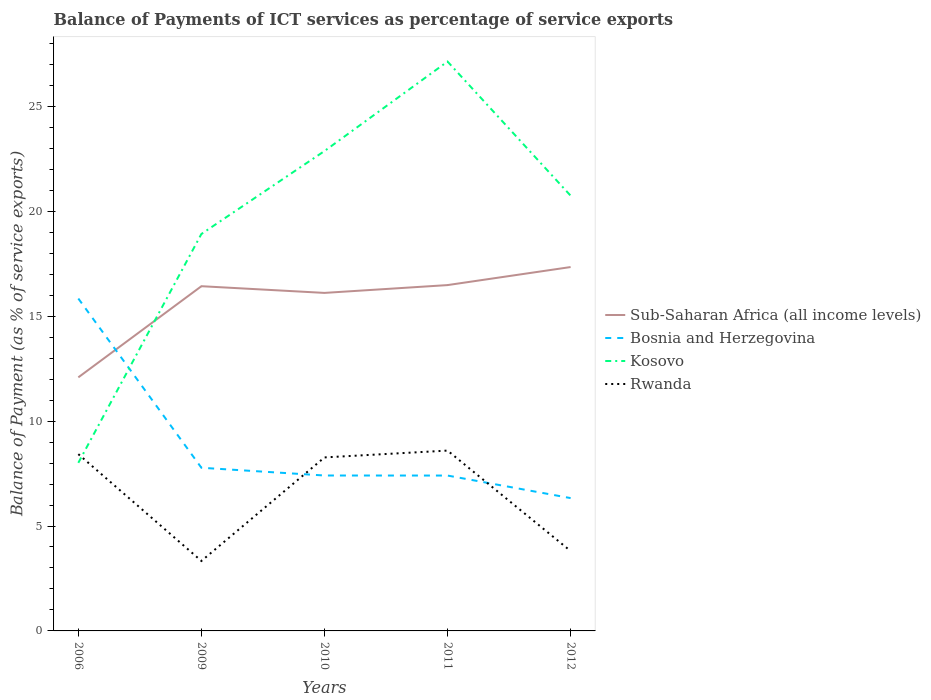Does the line corresponding to Sub-Saharan Africa (all income levels) intersect with the line corresponding to Rwanda?
Provide a succinct answer. No. Is the number of lines equal to the number of legend labels?
Your answer should be compact. Yes. Across all years, what is the maximum balance of payments of ICT services in Rwanda?
Your response must be concise. 3.33. What is the total balance of payments of ICT services in Kosovo in the graph?
Keep it short and to the point. -4.26. What is the difference between the highest and the second highest balance of payments of ICT services in Sub-Saharan Africa (all income levels)?
Make the answer very short. 5.26. What is the difference between the highest and the lowest balance of payments of ICT services in Bosnia and Herzegovina?
Offer a terse response. 1. How many lines are there?
Your response must be concise. 4. Are the values on the major ticks of Y-axis written in scientific E-notation?
Keep it short and to the point. No. Does the graph contain any zero values?
Offer a very short reply. No. Does the graph contain grids?
Provide a succinct answer. No. Where does the legend appear in the graph?
Make the answer very short. Center right. How many legend labels are there?
Ensure brevity in your answer.  4. How are the legend labels stacked?
Ensure brevity in your answer.  Vertical. What is the title of the graph?
Provide a succinct answer. Balance of Payments of ICT services as percentage of service exports. Does "Senegal" appear as one of the legend labels in the graph?
Make the answer very short. No. What is the label or title of the X-axis?
Give a very brief answer. Years. What is the label or title of the Y-axis?
Give a very brief answer. Balance of Payment (as % of service exports). What is the Balance of Payment (as % of service exports) in Sub-Saharan Africa (all income levels) in 2006?
Ensure brevity in your answer.  12.08. What is the Balance of Payment (as % of service exports) in Bosnia and Herzegovina in 2006?
Your answer should be compact. 15.84. What is the Balance of Payment (as % of service exports) of Kosovo in 2006?
Offer a very short reply. 8.01. What is the Balance of Payment (as % of service exports) in Rwanda in 2006?
Offer a terse response. 8.42. What is the Balance of Payment (as % of service exports) in Sub-Saharan Africa (all income levels) in 2009?
Your answer should be compact. 16.43. What is the Balance of Payment (as % of service exports) in Bosnia and Herzegovina in 2009?
Keep it short and to the point. 7.78. What is the Balance of Payment (as % of service exports) of Kosovo in 2009?
Keep it short and to the point. 18.92. What is the Balance of Payment (as % of service exports) of Rwanda in 2009?
Make the answer very short. 3.33. What is the Balance of Payment (as % of service exports) of Sub-Saharan Africa (all income levels) in 2010?
Provide a short and direct response. 16.11. What is the Balance of Payment (as % of service exports) in Bosnia and Herzegovina in 2010?
Make the answer very short. 7.41. What is the Balance of Payment (as % of service exports) of Kosovo in 2010?
Your answer should be compact. 22.87. What is the Balance of Payment (as % of service exports) in Rwanda in 2010?
Ensure brevity in your answer.  8.27. What is the Balance of Payment (as % of service exports) of Sub-Saharan Africa (all income levels) in 2011?
Ensure brevity in your answer.  16.48. What is the Balance of Payment (as % of service exports) of Bosnia and Herzegovina in 2011?
Your response must be concise. 7.4. What is the Balance of Payment (as % of service exports) of Kosovo in 2011?
Your response must be concise. 27.13. What is the Balance of Payment (as % of service exports) of Rwanda in 2011?
Offer a terse response. 8.59. What is the Balance of Payment (as % of service exports) of Sub-Saharan Africa (all income levels) in 2012?
Offer a very short reply. 17.34. What is the Balance of Payment (as % of service exports) in Bosnia and Herzegovina in 2012?
Provide a succinct answer. 6.33. What is the Balance of Payment (as % of service exports) in Kosovo in 2012?
Keep it short and to the point. 20.74. What is the Balance of Payment (as % of service exports) of Rwanda in 2012?
Provide a short and direct response. 3.81. Across all years, what is the maximum Balance of Payment (as % of service exports) in Sub-Saharan Africa (all income levels)?
Your answer should be compact. 17.34. Across all years, what is the maximum Balance of Payment (as % of service exports) in Bosnia and Herzegovina?
Your answer should be compact. 15.84. Across all years, what is the maximum Balance of Payment (as % of service exports) in Kosovo?
Provide a succinct answer. 27.13. Across all years, what is the maximum Balance of Payment (as % of service exports) in Rwanda?
Provide a short and direct response. 8.59. Across all years, what is the minimum Balance of Payment (as % of service exports) in Sub-Saharan Africa (all income levels)?
Make the answer very short. 12.08. Across all years, what is the minimum Balance of Payment (as % of service exports) of Bosnia and Herzegovina?
Provide a succinct answer. 6.33. Across all years, what is the minimum Balance of Payment (as % of service exports) in Kosovo?
Your response must be concise. 8.01. Across all years, what is the minimum Balance of Payment (as % of service exports) of Rwanda?
Give a very brief answer. 3.33. What is the total Balance of Payment (as % of service exports) in Sub-Saharan Africa (all income levels) in the graph?
Your response must be concise. 78.44. What is the total Balance of Payment (as % of service exports) of Bosnia and Herzegovina in the graph?
Offer a very short reply. 44.76. What is the total Balance of Payment (as % of service exports) in Kosovo in the graph?
Your answer should be very brief. 97.67. What is the total Balance of Payment (as % of service exports) of Rwanda in the graph?
Offer a very short reply. 32.43. What is the difference between the Balance of Payment (as % of service exports) in Sub-Saharan Africa (all income levels) in 2006 and that in 2009?
Give a very brief answer. -4.34. What is the difference between the Balance of Payment (as % of service exports) of Bosnia and Herzegovina in 2006 and that in 2009?
Ensure brevity in your answer.  8.06. What is the difference between the Balance of Payment (as % of service exports) in Kosovo in 2006 and that in 2009?
Provide a short and direct response. -10.91. What is the difference between the Balance of Payment (as % of service exports) in Rwanda in 2006 and that in 2009?
Offer a terse response. 5.09. What is the difference between the Balance of Payment (as % of service exports) of Sub-Saharan Africa (all income levels) in 2006 and that in 2010?
Your answer should be very brief. -4.02. What is the difference between the Balance of Payment (as % of service exports) of Bosnia and Herzegovina in 2006 and that in 2010?
Provide a short and direct response. 8.43. What is the difference between the Balance of Payment (as % of service exports) of Kosovo in 2006 and that in 2010?
Keep it short and to the point. -14.86. What is the difference between the Balance of Payment (as % of service exports) of Rwanda in 2006 and that in 2010?
Make the answer very short. 0.16. What is the difference between the Balance of Payment (as % of service exports) in Sub-Saharan Africa (all income levels) in 2006 and that in 2011?
Your answer should be very brief. -4.4. What is the difference between the Balance of Payment (as % of service exports) in Bosnia and Herzegovina in 2006 and that in 2011?
Offer a very short reply. 8.44. What is the difference between the Balance of Payment (as % of service exports) of Kosovo in 2006 and that in 2011?
Your response must be concise. -19.12. What is the difference between the Balance of Payment (as % of service exports) of Rwanda in 2006 and that in 2011?
Keep it short and to the point. -0.17. What is the difference between the Balance of Payment (as % of service exports) of Sub-Saharan Africa (all income levels) in 2006 and that in 2012?
Offer a very short reply. -5.26. What is the difference between the Balance of Payment (as % of service exports) of Bosnia and Herzegovina in 2006 and that in 2012?
Make the answer very short. 9.51. What is the difference between the Balance of Payment (as % of service exports) of Kosovo in 2006 and that in 2012?
Your answer should be compact. -12.73. What is the difference between the Balance of Payment (as % of service exports) of Rwanda in 2006 and that in 2012?
Provide a succinct answer. 4.62. What is the difference between the Balance of Payment (as % of service exports) in Sub-Saharan Africa (all income levels) in 2009 and that in 2010?
Provide a short and direct response. 0.32. What is the difference between the Balance of Payment (as % of service exports) of Bosnia and Herzegovina in 2009 and that in 2010?
Ensure brevity in your answer.  0.37. What is the difference between the Balance of Payment (as % of service exports) in Kosovo in 2009 and that in 2010?
Ensure brevity in your answer.  -3.95. What is the difference between the Balance of Payment (as % of service exports) in Rwanda in 2009 and that in 2010?
Give a very brief answer. -4.93. What is the difference between the Balance of Payment (as % of service exports) in Sub-Saharan Africa (all income levels) in 2009 and that in 2011?
Offer a terse response. -0.05. What is the difference between the Balance of Payment (as % of service exports) of Bosnia and Herzegovina in 2009 and that in 2011?
Offer a terse response. 0.37. What is the difference between the Balance of Payment (as % of service exports) in Kosovo in 2009 and that in 2011?
Give a very brief answer. -8.22. What is the difference between the Balance of Payment (as % of service exports) of Rwanda in 2009 and that in 2011?
Provide a short and direct response. -5.26. What is the difference between the Balance of Payment (as % of service exports) of Sub-Saharan Africa (all income levels) in 2009 and that in 2012?
Offer a terse response. -0.91. What is the difference between the Balance of Payment (as % of service exports) in Bosnia and Herzegovina in 2009 and that in 2012?
Give a very brief answer. 1.45. What is the difference between the Balance of Payment (as % of service exports) in Kosovo in 2009 and that in 2012?
Make the answer very short. -1.82. What is the difference between the Balance of Payment (as % of service exports) of Rwanda in 2009 and that in 2012?
Your answer should be compact. -0.47. What is the difference between the Balance of Payment (as % of service exports) of Sub-Saharan Africa (all income levels) in 2010 and that in 2011?
Make the answer very short. -0.37. What is the difference between the Balance of Payment (as % of service exports) in Bosnia and Herzegovina in 2010 and that in 2011?
Your answer should be compact. 0. What is the difference between the Balance of Payment (as % of service exports) of Kosovo in 2010 and that in 2011?
Ensure brevity in your answer.  -4.26. What is the difference between the Balance of Payment (as % of service exports) of Rwanda in 2010 and that in 2011?
Ensure brevity in your answer.  -0.33. What is the difference between the Balance of Payment (as % of service exports) in Sub-Saharan Africa (all income levels) in 2010 and that in 2012?
Offer a very short reply. -1.23. What is the difference between the Balance of Payment (as % of service exports) in Bosnia and Herzegovina in 2010 and that in 2012?
Ensure brevity in your answer.  1.08. What is the difference between the Balance of Payment (as % of service exports) of Kosovo in 2010 and that in 2012?
Keep it short and to the point. 2.13. What is the difference between the Balance of Payment (as % of service exports) in Rwanda in 2010 and that in 2012?
Provide a succinct answer. 4.46. What is the difference between the Balance of Payment (as % of service exports) in Sub-Saharan Africa (all income levels) in 2011 and that in 2012?
Provide a succinct answer. -0.86. What is the difference between the Balance of Payment (as % of service exports) in Bosnia and Herzegovina in 2011 and that in 2012?
Offer a terse response. 1.07. What is the difference between the Balance of Payment (as % of service exports) of Kosovo in 2011 and that in 2012?
Your answer should be compact. 6.39. What is the difference between the Balance of Payment (as % of service exports) in Rwanda in 2011 and that in 2012?
Your response must be concise. 4.79. What is the difference between the Balance of Payment (as % of service exports) of Sub-Saharan Africa (all income levels) in 2006 and the Balance of Payment (as % of service exports) of Bosnia and Herzegovina in 2009?
Offer a terse response. 4.31. What is the difference between the Balance of Payment (as % of service exports) of Sub-Saharan Africa (all income levels) in 2006 and the Balance of Payment (as % of service exports) of Kosovo in 2009?
Your answer should be very brief. -6.83. What is the difference between the Balance of Payment (as % of service exports) of Sub-Saharan Africa (all income levels) in 2006 and the Balance of Payment (as % of service exports) of Rwanda in 2009?
Your answer should be compact. 8.75. What is the difference between the Balance of Payment (as % of service exports) of Bosnia and Herzegovina in 2006 and the Balance of Payment (as % of service exports) of Kosovo in 2009?
Your answer should be compact. -3.08. What is the difference between the Balance of Payment (as % of service exports) of Bosnia and Herzegovina in 2006 and the Balance of Payment (as % of service exports) of Rwanda in 2009?
Make the answer very short. 12.51. What is the difference between the Balance of Payment (as % of service exports) of Kosovo in 2006 and the Balance of Payment (as % of service exports) of Rwanda in 2009?
Your answer should be compact. 4.68. What is the difference between the Balance of Payment (as % of service exports) in Sub-Saharan Africa (all income levels) in 2006 and the Balance of Payment (as % of service exports) in Bosnia and Herzegovina in 2010?
Keep it short and to the point. 4.68. What is the difference between the Balance of Payment (as % of service exports) of Sub-Saharan Africa (all income levels) in 2006 and the Balance of Payment (as % of service exports) of Kosovo in 2010?
Provide a short and direct response. -10.78. What is the difference between the Balance of Payment (as % of service exports) in Sub-Saharan Africa (all income levels) in 2006 and the Balance of Payment (as % of service exports) in Rwanda in 2010?
Keep it short and to the point. 3.82. What is the difference between the Balance of Payment (as % of service exports) of Bosnia and Herzegovina in 2006 and the Balance of Payment (as % of service exports) of Kosovo in 2010?
Your answer should be compact. -7.03. What is the difference between the Balance of Payment (as % of service exports) of Bosnia and Herzegovina in 2006 and the Balance of Payment (as % of service exports) of Rwanda in 2010?
Provide a succinct answer. 7.57. What is the difference between the Balance of Payment (as % of service exports) in Kosovo in 2006 and the Balance of Payment (as % of service exports) in Rwanda in 2010?
Your response must be concise. -0.26. What is the difference between the Balance of Payment (as % of service exports) of Sub-Saharan Africa (all income levels) in 2006 and the Balance of Payment (as % of service exports) of Bosnia and Herzegovina in 2011?
Your response must be concise. 4.68. What is the difference between the Balance of Payment (as % of service exports) in Sub-Saharan Africa (all income levels) in 2006 and the Balance of Payment (as % of service exports) in Kosovo in 2011?
Your response must be concise. -15.05. What is the difference between the Balance of Payment (as % of service exports) of Sub-Saharan Africa (all income levels) in 2006 and the Balance of Payment (as % of service exports) of Rwanda in 2011?
Your answer should be very brief. 3.49. What is the difference between the Balance of Payment (as % of service exports) in Bosnia and Herzegovina in 2006 and the Balance of Payment (as % of service exports) in Kosovo in 2011?
Give a very brief answer. -11.29. What is the difference between the Balance of Payment (as % of service exports) in Bosnia and Herzegovina in 2006 and the Balance of Payment (as % of service exports) in Rwanda in 2011?
Ensure brevity in your answer.  7.25. What is the difference between the Balance of Payment (as % of service exports) of Kosovo in 2006 and the Balance of Payment (as % of service exports) of Rwanda in 2011?
Ensure brevity in your answer.  -0.58. What is the difference between the Balance of Payment (as % of service exports) of Sub-Saharan Africa (all income levels) in 2006 and the Balance of Payment (as % of service exports) of Bosnia and Herzegovina in 2012?
Your response must be concise. 5.75. What is the difference between the Balance of Payment (as % of service exports) in Sub-Saharan Africa (all income levels) in 2006 and the Balance of Payment (as % of service exports) in Kosovo in 2012?
Your answer should be compact. -8.66. What is the difference between the Balance of Payment (as % of service exports) of Sub-Saharan Africa (all income levels) in 2006 and the Balance of Payment (as % of service exports) of Rwanda in 2012?
Provide a short and direct response. 8.28. What is the difference between the Balance of Payment (as % of service exports) in Bosnia and Herzegovina in 2006 and the Balance of Payment (as % of service exports) in Kosovo in 2012?
Make the answer very short. -4.9. What is the difference between the Balance of Payment (as % of service exports) in Bosnia and Herzegovina in 2006 and the Balance of Payment (as % of service exports) in Rwanda in 2012?
Give a very brief answer. 12.03. What is the difference between the Balance of Payment (as % of service exports) of Kosovo in 2006 and the Balance of Payment (as % of service exports) of Rwanda in 2012?
Your response must be concise. 4.2. What is the difference between the Balance of Payment (as % of service exports) in Sub-Saharan Africa (all income levels) in 2009 and the Balance of Payment (as % of service exports) in Bosnia and Herzegovina in 2010?
Keep it short and to the point. 9.02. What is the difference between the Balance of Payment (as % of service exports) in Sub-Saharan Africa (all income levels) in 2009 and the Balance of Payment (as % of service exports) in Kosovo in 2010?
Your response must be concise. -6.44. What is the difference between the Balance of Payment (as % of service exports) of Sub-Saharan Africa (all income levels) in 2009 and the Balance of Payment (as % of service exports) of Rwanda in 2010?
Ensure brevity in your answer.  8.16. What is the difference between the Balance of Payment (as % of service exports) in Bosnia and Herzegovina in 2009 and the Balance of Payment (as % of service exports) in Kosovo in 2010?
Provide a short and direct response. -15.09. What is the difference between the Balance of Payment (as % of service exports) in Bosnia and Herzegovina in 2009 and the Balance of Payment (as % of service exports) in Rwanda in 2010?
Make the answer very short. -0.49. What is the difference between the Balance of Payment (as % of service exports) of Kosovo in 2009 and the Balance of Payment (as % of service exports) of Rwanda in 2010?
Your answer should be compact. 10.65. What is the difference between the Balance of Payment (as % of service exports) in Sub-Saharan Africa (all income levels) in 2009 and the Balance of Payment (as % of service exports) in Bosnia and Herzegovina in 2011?
Ensure brevity in your answer.  9.02. What is the difference between the Balance of Payment (as % of service exports) of Sub-Saharan Africa (all income levels) in 2009 and the Balance of Payment (as % of service exports) of Kosovo in 2011?
Ensure brevity in your answer.  -10.71. What is the difference between the Balance of Payment (as % of service exports) of Sub-Saharan Africa (all income levels) in 2009 and the Balance of Payment (as % of service exports) of Rwanda in 2011?
Offer a terse response. 7.83. What is the difference between the Balance of Payment (as % of service exports) of Bosnia and Herzegovina in 2009 and the Balance of Payment (as % of service exports) of Kosovo in 2011?
Offer a terse response. -19.36. What is the difference between the Balance of Payment (as % of service exports) in Bosnia and Herzegovina in 2009 and the Balance of Payment (as % of service exports) in Rwanda in 2011?
Your answer should be very brief. -0.82. What is the difference between the Balance of Payment (as % of service exports) in Kosovo in 2009 and the Balance of Payment (as % of service exports) in Rwanda in 2011?
Keep it short and to the point. 10.32. What is the difference between the Balance of Payment (as % of service exports) of Sub-Saharan Africa (all income levels) in 2009 and the Balance of Payment (as % of service exports) of Bosnia and Herzegovina in 2012?
Your answer should be very brief. 10.1. What is the difference between the Balance of Payment (as % of service exports) in Sub-Saharan Africa (all income levels) in 2009 and the Balance of Payment (as % of service exports) in Kosovo in 2012?
Your response must be concise. -4.31. What is the difference between the Balance of Payment (as % of service exports) of Sub-Saharan Africa (all income levels) in 2009 and the Balance of Payment (as % of service exports) of Rwanda in 2012?
Give a very brief answer. 12.62. What is the difference between the Balance of Payment (as % of service exports) of Bosnia and Herzegovina in 2009 and the Balance of Payment (as % of service exports) of Kosovo in 2012?
Offer a very short reply. -12.97. What is the difference between the Balance of Payment (as % of service exports) of Bosnia and Herzegovina in 2009 and the Balance of Payment (as % of service exports) of Rwanda in 2012?
Give a very brief answer. 3.97. What is the difference between the Balance of Payment (as % of service exports) of Kosovo in 2009 and the Balance of Payment (as % of service exports) of Rwanda in 2012?
Ensure brevity in your answer.  15.11. What is the difference between the Balance of Payment (as % of service exports) in Sub-Saharan Africa (all income levels) in 2010 and the Balance of Payment (as % of service exports) in Bosnia and Herzegovina in 2011?
Give a very brief answer. 8.7. What is the difference between the Balance of Payment (as % of service exports) in Sub-Saharan Africa (all income levels) in 2010 and the Balance of Payment (as % of service exports) in Kosovo in 2011?
Keep it short and to the point. -11.03. What is the difference between the Balance of Payment (as % of service exports) in Sub-Saharan Africa (all income levels) in 2010 and the Balance of Payment (as % of service exports) in Rwanda in 2011?
Your answer should be very brief. 7.51. What is the difference between the Balance of Payment (as % of service exports) of Bosnia and Herzegovina in 2010 and the Balance of Payment (as % of service exports) of Kosovo in 2011?
Offer a very short reply. -19.73. What is the difference between the Balance of Payment (as % of service exports) of Bosnia and Herzegovina in 2010 and the Balance of Payment (as % of service exports) of Rwanda in 2011?
Your response must be concise. -1.19. What is the difference between the Balance of Payment (as % of service exports) in Kosovo in 2010 and the Balance of Payment (as % of service exports) in Rwanda in 2011?
Give a very brief answer. 14.28. What is the difference between the Balance of Payment (as % of service exports) of Sub-Saharan Africa (all income levels) in 2010 and the Balance of Payment (as % of service exports) of Bosnia and Herzegovina in 2012?
Your response must be concise. 9.78. What is the difference between the Balance of Payment (as % of service exports) of Sub-Saharan Africa (all income levels) in 2010 and the Balance of Payment (as % of service exports) of Kosovo in 2012?
Your answer should be compact. -4.63. What is the difference between the Balance of Payment (as % of service exports) of Sub-Saharan Africa (all income levels) in 2010 and the Balance of Payment (as % of service exports) of Rwanda in 2012?
Keep it short and to the point. 12.3. What is the difference between the Balance of Payment (as % of service exports) of Bosnia and Herzegovina in 2010 and the Balance of Payment (as % of service exports) of Kosovo in 2012?
Your answer should be very brief. -13.33. What is the difference between the Balance of Payment (as % of service exports) of Bosnia and Herzegovina in 2010 and the Balance of Payment (as % of service exports) of Rwanda in 2012?
Make the answer very short. 3.6. What is the difference between the Balance of Payment (as % of service exports) in Kosovo in 2010 and the Balance of Payment (as % of service exports) in Rwanda in 2012?
Offer a terse response. 19.06. What is the difference between the Balance of Payment (as % of service exports) of Sub-Saharan Africa (all income levels) in 2011 and the Balance of Payment (as % of service exports) of Bosnia and Herzegovina in 2012?
Make the answer very short. 10.15. What is the difference between the Balance of Payment (as % of service exports) in Sub-Saharan Africa (all income levels) in 2011 and the Balance of Payment (as % of service exports) in Kosovo in 2012?
Your answer should be compact. -4.26. What is the difference between the Balance of Payment (as % of service exports) of Sub-Saharan Africa (all income levels) in 2011 and the Balance of Payment (as % of service exports) of Rwanda in 2012?
Keep it short and to the point. 12.67. What is the difference between the Balance of Payment (as % of service exports) in Bosnia and Herzegovina in 2011 and the Balance of Payment (as % of service exports) in Kosovo in 2012?
Your answer should be compact. -13.34. What is the difference between the Balance of Payment (as % of service exports) of Bosnia and Herzegovina in 2011 and the Balance of Payment (as % of service exports) of Rwanda in 2012?
Make the answer very short. 3.6. What is the difference between the Balance of Payment (as % of service exports) of Kosovo in 2011 and the Balance of Payment (as % of service exports) of Rwanda in 2012?
Keep it short and to the point. 23.33. What is the average Balance of Payment (as % of service exports) in Sub-Saharan Africa (all income levels) per year?
Your answer should be compact. 15.69. What is the average Balance of Payment (as % of service exports) in Bosnia and Herzegovina per year?
Your answer should be compact. 8.95. What is the average Balance of Payment (as % of service exports) of Kosovo per year?
Make the answer very short. 19.53. What is the average Balance of Payment (as % of service exports) in Rwanda per year?
Your response must be concise. 6.49. In the year 2006, what is the difference between the Balance of Payment (as % of service exports) in Sub-Saharan Africa (all income levels) and Balance of Payment (as % of service exports) in Bosnia and Herzegovina?
Give a very brief answer. -3.76. In the year 2006, what is the difference between the Balance of Payment (as % of service exports) of Sub-Saharan Africa (all income levels) and Balance of Payment (as % of service exports) of Kosovo?
Offer a very short reply. 4.07. In the year 2006, what is the difference between the Balance of Payment (as % of service exports) of Sub-Saharan Africa (all income levels) and Balance of Payment (as % of service exports) of Rwanda?
Your answer should be very brief. 3.66. In the year 2006, what is the difference between the Balance of Payment (as % of service exports) in Bosnia and Herzegovina and Balance of Payment (as % of service exports) in Kosovo?
Provide a short and direct response. 7.83. In the year 2006, what is the difference between the Balance of Payment (as % of service exports) of Bosnia and Herzegovina and Balance of Payment (as % of service exports) of Rwanda?
Your answer should be very brief. 7.42. In the year 2006, what is the difference between the Balance of Payment (as % of service exports) of Kosovo and Balance of Payment (as % of service exports) of Rwanda?
Give a very brief answer. -0.41. In the year 2009, what is the difference between the Balance of Payment (as % of service exports) of Sub-Saharan Africa (all income levels) and Balance of Payment (as % of service exports) of Bosnia and Herzegovina?
Provide a short and direct response. 8.65. In the year 2009, what is the difference between the Balance of Payment (as % of service exports) in Sub-Saharan Africa (all income levels) and Balance of Payment (as % of service exports) in Kosovo?
Your answer should be very brief. -2.49. In the year 2009, what is the difference between the Balance of Payment (as % of service exports) in Sub-Saharan Africa (all income levels) and Balance of Payment (as % of service exports) in Rwanda?
Provide a succinct answer. 13.09. In the year 2009, what is the difference between the Balance of Payment (as % of service exports) in Bosnia and Herzegovina and Balance of Payment (as % of service exports) in Kosovo?
Offer a terse response. -11.14. In the year 2009, what is the difference between the Balance of Payment (as % of service exports) in Bosnia and Herzegovina and Balance of Payment (as % of service exports) in Rwanda?
Your answer should be compact. 4.44. In the year 2009, what is the difference between the Balance of Payment (as % of service exports) in Kosovo and Balance of Payment (as % of service exports) in Rwanda?
Give a very brief answer. 15.58. In the year 2010, what is the difference between the Balance of Payment (as % of service exports) in Sub-Saharan Africa (all income levels) and Balance of Payment (as % of service exports) in Bosnia and Herzegovina?
Ensure brevity in your answer.  8.7. In the year 2010, what is the difference between the Balance of Payment (as % of service exports) in Sub-Saharan Africa (all income levels) and Balance of Payment (as % of service exports) in Kosovo?
Give a very brief answer. -6.76. In the year 2010, what is the difference between the Balance of Payment (as % of service exports) in Sub-Saharan Africa (all income levels) and Balance of Payment (as % of service exports) in Rwanda?
Your response must be concise. 7.84. In the year 2010, what is the difference between the Balance of Payment (as % of service exports) of Bosnia and Herzegovina and Balance of Payment (as % of service exports) of Kosovo?
Provide a short and direct response. -15.46. In the year 2010, what is the difference between the Balance of Payment (as % of service exports) of Bosnia and Herzegovina and Balance of Payment (as % of service exports) of Rwanda?
Give a very brief answer. -0.86. In the year 2010, what is the difference between the Balance of Payment (as % of service exports) of Kosovo and Balance of Payment (as % of service exports) of Rwanda?
Offer a terse response. 14.6. In the year 2011, what is the difference between the Balance of Payment (as % of service exports) in Sub-Saharan Africa (all income levels) and Balance of Payment (as % of service exports) in Bosnia and Herzegovina?
Give a very brief answer. 9.08. In the year 2011, what is the difference between the Balance of Payment (as % of service exports) of Sub-Saharan Africa (all income levels) and Balance of Payment (as % of service exports) of Kosovo?
Keep it short and to the point. -10.65. In the year 2011, what is the difference between the Balance of Payment (as % of service exports) in Sub-Saharan Africa (all income levels) and Balance of Payment (as % of service exports) in Rwanda?
Offer a terse response. 7.89. In the year 2011, what is the difference between the Balance of Payment (as % of service exports) of Bosnia and Herzegovina and Balance of Payment (as % of service exports) of Kosovo?
Your answer should be compact. -19.73. In the year 2011, what is the difference between the Balance of Payment (as % of service exports) in Bosnia and Herzegovina and Balance of Payment (as % of service exports) in Rwanda?
Your answer should be very brief. -1.19. In the year 2011, what is the difference between the Balance of Payment (as % of service exports) in Kosovo and Balance of Payment (as % of service exports) in Rwanda?
Your answer should be very brief. 18.54. In the year 2012, what is the difference between the Balance of Payment (as % of service exports) of Sub-Saharan Africa (all income levels) and Balance of Payment (as % of service exports) of Bosnia and Herzegovina?
Offer a very short reply. 11.01. In the year 2012, what is the difference between the Balance of Payment (as % of service exports) of Sub-Saharan Africa (all income levels) and Balance of Payment (as % of service exports) of Kosovo?
Keep it short and to the point. -3.4. In the year 2012, what is the difference between the Balance of Payment (as % of service exports) of Sub-Saharan Africa (all income levels) and Balance of Payment (as % of service exports) of Rwanda?
Give a very brief answer. 13.53. In the year 2012, what is the difference between the Balance of Payment (as % of service exports) of Bosnia and Herzegovina and Balance of Payment (as % of service exports) of Kosovo?
Provide a succinct answer. -14.41. In the year 2012, what is the difference between the Balance of Payment (as % of service exports) in Bosnia and Herzegovina and Balance of Payment (as % of service exports) in Rwanda?
Make the answer very short. 2.52. In the year 2012, what is the difference between the Balance of Payment (as % of service exports) in Kosovo and Balance of Payment (as % of service exports) in Rwanda?
Your answer should be compact. 16.93. What is the ratio of the Balance of Payment (as % of service exports) of Sub-Saharan Africa (all income levels) in 2006 to that in 2009?
Your answer should be very brief. 0.74. What is the ratio of the Balance of Payment (as % of service exports) of Bosnia and Herzegovina in 2006 to that in 2009?
Ensure brevity in your answer.  2.04. What is the ratio of the Balance of Payment (as % of service exports) of Kosovo in 2006 to that in 2009?
Your answer should be very brief. 0.42. What is the ratio of the Balance of Payment (as % of service exports) of Rwanda in 2006 to that in 2009?
Your answer should be compact. 2.53. What is the ratio of the Balance of Payment (as % of service exports) in Sub-Saharan Africa (all income levels) in 2006 to that in 2010?
Offer a terse response. 0.75. What is the ratio of the Balance of Payment (as % of service exports) in Bosnia and Herzegovina in 2006 to that in 2010?
Make the answer very short. 2.14. What is the ratio of the Balance of Payment (as % of service exports) in Kosovo in 2006 to that in 2010?
Provide a succinct answer. 0.35. What is the ratio of the Balance of Payment (as % of service exports) of Rwanda in 2006 to that in 2010?
Your response must be concise. 1.02. What is the ratio of the Balance of Payment (as % of service exports) in Sub-Saharan Africa (all income levels) in 2006 to that in 2011?
Provide a succinct answer. 0.73. What is the ratio of the Balance of Payment (as % of service exports) of Bosnia and Herzegovina in 2006 to that in 2011?
Ensure brevity in your answer.  2.14. What is the ratio of the Balance of Payment (as % of service exports) of Kosovo in 2006 to that in 2011?
Offer a very short reply. 0.3. What is the ratio of the Balance of Payment (as % of service exports) of Rwanda in 2006 to that in 2011?
Your answer should be compact. 0.98. What is the ratio of the Balance of Payment (as % of service exports) of Sub-Saharan Africa (all income levels) in 2006 to that in 2012?
Your answer should be compact. 0.7. What is the ratio of the Balance of Payment (as % of service exports) of Bosnia and Herzegovina in 2006 to that in 2012?
Your answer should be very brief. 2.5. What is the ratio of the Balance of Payment (as % of service exports) of Kosovo in 2006 to that in 2012?
Your answer should be very brief. 0.39. What is the ratio of the Balance of Payment (as % of service exports) in Rwanda in 2006 to that in 2012?
Provide a short and direct response. 2.21. What is the ratio of the Balance of Payment (as % of service exports) of Sub-Saharan Africa (all income levels) in 2009 to that in 2010?
Offer a terse response. 1.02. What is the ratio of the Balance of Payment (as % of service exports) in Bosnia and Herzegovina in 2009 to that in 2010?
Give a very brief answer. 1.05. What is the ratio of the Balance of Payment (as % of service exports) in Kosovo in 2009 to that in 2010?
Ensure brevity in your answer.  0.83. What is the ratio of the Balance of Payment (as % of service exports) of Rwanda in 2009 to that in 2010?
Offer a very short reply. 0.4. What is the ratio of the Balance of Payment (as % of service exports) of Bosnia and Herzegovina in 2009 to that in 2011?
Provide a succinct answer. 1.05. What is the ratio of the Balance of Payment (as % of service exports) in Kosovo in 2009 to that in 2011?
Your answer should be very brief. 0.7. What is the ratio of the Balance of Payment (as % of service exports) of Rwanda in 2009 to that in 2011?
Keep it short and to the point. 0.39. What is the ratio of the Balance of Payment (as % of service exports) of Sub-Saharan Africa (all income levels) in 2009 to that in 2012?
Provide a succinct answer. 0.95. What is the ratio of the Balance of Payment (as % of service exports) of Bosnia and Herzegovina in 2009 to that in 2012?
Your answer should be very brief. 1.23. What is the ratio of the Balance of Payment (as % of service exports) in Kosovo in 2009 to that in 2012?
Provide a succinct answer. 0.91. What is the ratio of the Balance of Payment (as % of service exports) of Rwanda in 2009 to that in 2012?
Your response must be concise. 0.88. What is the ratio of the Balance of Payment (as % of service exports) of Sub-Saharan Africa (all income levels) in 2010 to that in 2011?
Ensure brevity in your answer.  0.98. What is the ratio of the Balance of Payment (as % of service exports) in Kosovo in 2010 to that in 2011?
Ensure brevity in your answer.  0.84. What is the ratio of the Balance of Payment (as % of service exports) in Rwanda in 2010 to that in 2011?
Offer a terse response. 0.96. What is the ratio of the Balance of Payment (as % of service exports) of Sub-Saharan Africa (all income levels) in 2010 to that in 2012?
Keep it short and to the point. 0.93. What is the ratio of the Balance of Payment (as % of service exports) in Bosnia and Herzegovina in 2010 to that in 2012?
Ensure brevity in your answer.  1.17. What is the ratio of the Balance of Payment (as % of service exports) in Kosovo in 2010 to that in 2012?
Your answer should be compact. 1.1. What is the ratio of the Balance of Payment (as % of service exports) of Rwanda in 2010 to that in 2012?
Give a very brief answer. 2.17. What is the ratio of the Balance of Payment (as % of service exports) of Sub-Saharan Africa (all income levels) in 2011 to that in 2012?
Make the answer very short. 0.95. What is the ratio of the Balance of Payment (as % of service exports) in Bosnia and Herzegovina in 2011 to that in 2012?
Ensure brevity in your answer.  1.17. What is the ratio of the Balance of Payment (as % of service exports) in Kosovo in 2011 to that in 2012?
Your response must be concise. 1.31. What is the ratio of the Balance of Payment (as % of service exports) in Rwanda in 2011 to that in 2012?
Keep it short and to the point. 2.26. What is the difference between the highest and the second highest Balance of Payment (as % of service exports) of Sub-Saharan Africa (all income levels)?
Keep it short and to the point. 0.86. What is the difference between the highest and the second highest Balance of Payment (as % of service exports) in Bosnia and Herzegovina?
Your answer should be compact. 8.06. What is the difference between the highest and the second highest Balance of Payment (as % of service exports) in Kosovo?
Your answer should be very brief. 4.26. What is the difference between the highest and the second highest Balance of Payment (as % of service exports) of Rwanda?
Give a very brief answer. 0.17. What is the difference between the highest and the lowest Balance of Payment (as % of service exports) in Sub-Saharan Africa (all income levels)?
Your response must be concise. 5.26. What is the difference between the highest and the lowest Balance of Payment (as % of service exports) in Bosnia and Herzegovina?
Make the answer very short. 9.51. What is the difference between the highest and the lowest Balance of Payment (as % of service exports) of Kosovo?
Make the answer very short. 19.12. What is the difference between the highest and the lowest Balance of Payment (as % of service exports) in Rwanda?
Keep it short and to the point. 5.26. 